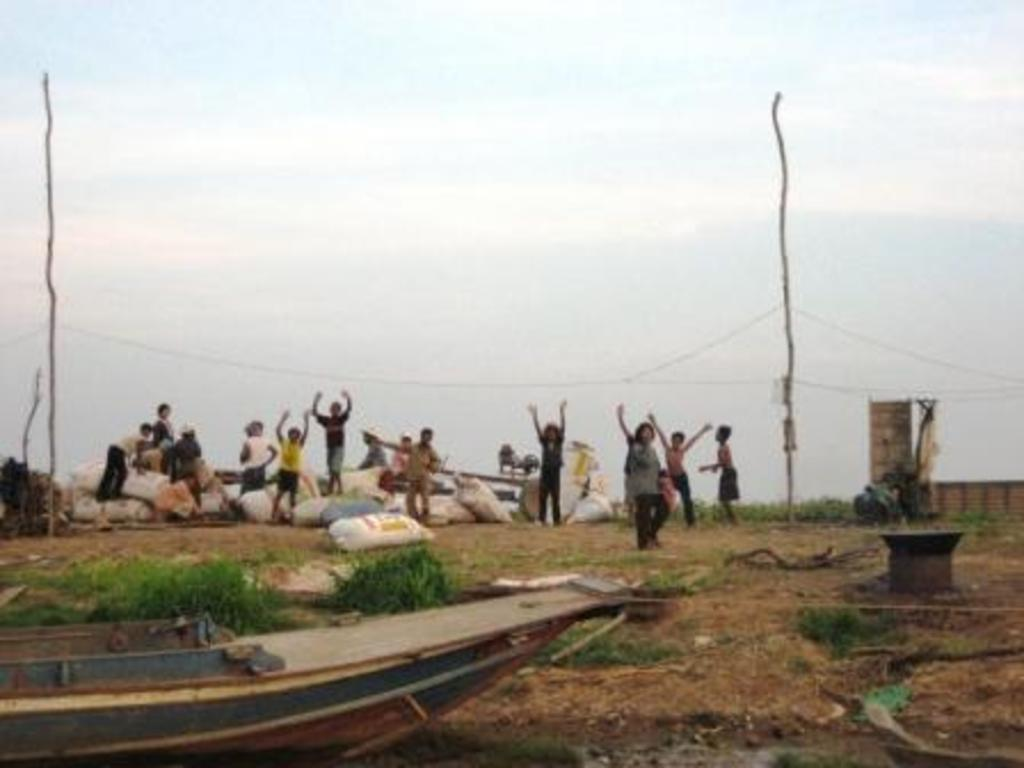How many people are in the image? There are people in the image, but the exact number is not specified. What type of terrain is visible in the image? There is grass in the image, which suggests a natural setting. What is the main mode of transportation in the image? There is a boat in the image, which is a common means of transportation on water. What color are the bags in the image? The bags in the image are white. What are the wires and poles used for in the image? The wires and poles are likely used for supporting electrical or communication infrastructure. What is visible in the sky in the image? The sky is visible in the image, but the weather or time of day is not specified. What type of gun can be seen in the hands of the people in the image? There is no mention of a gun or any weapon in the image. What kind of fight is taking place between the people in the image? There is no indication of a fight or any conflict between the people in the image. 